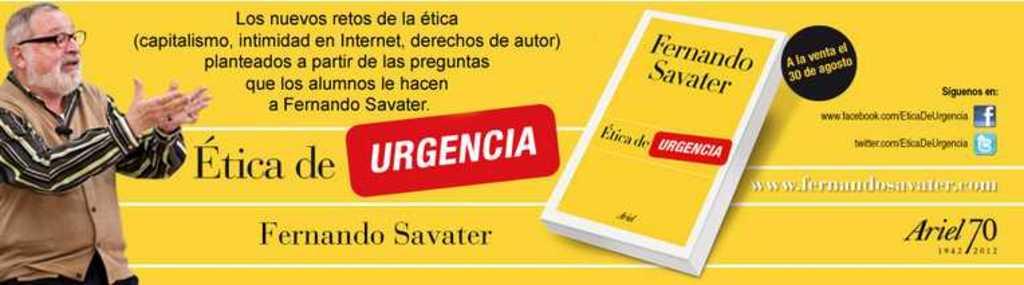Who wrote the book?
Your answer should be very brief. Fernando savater. 